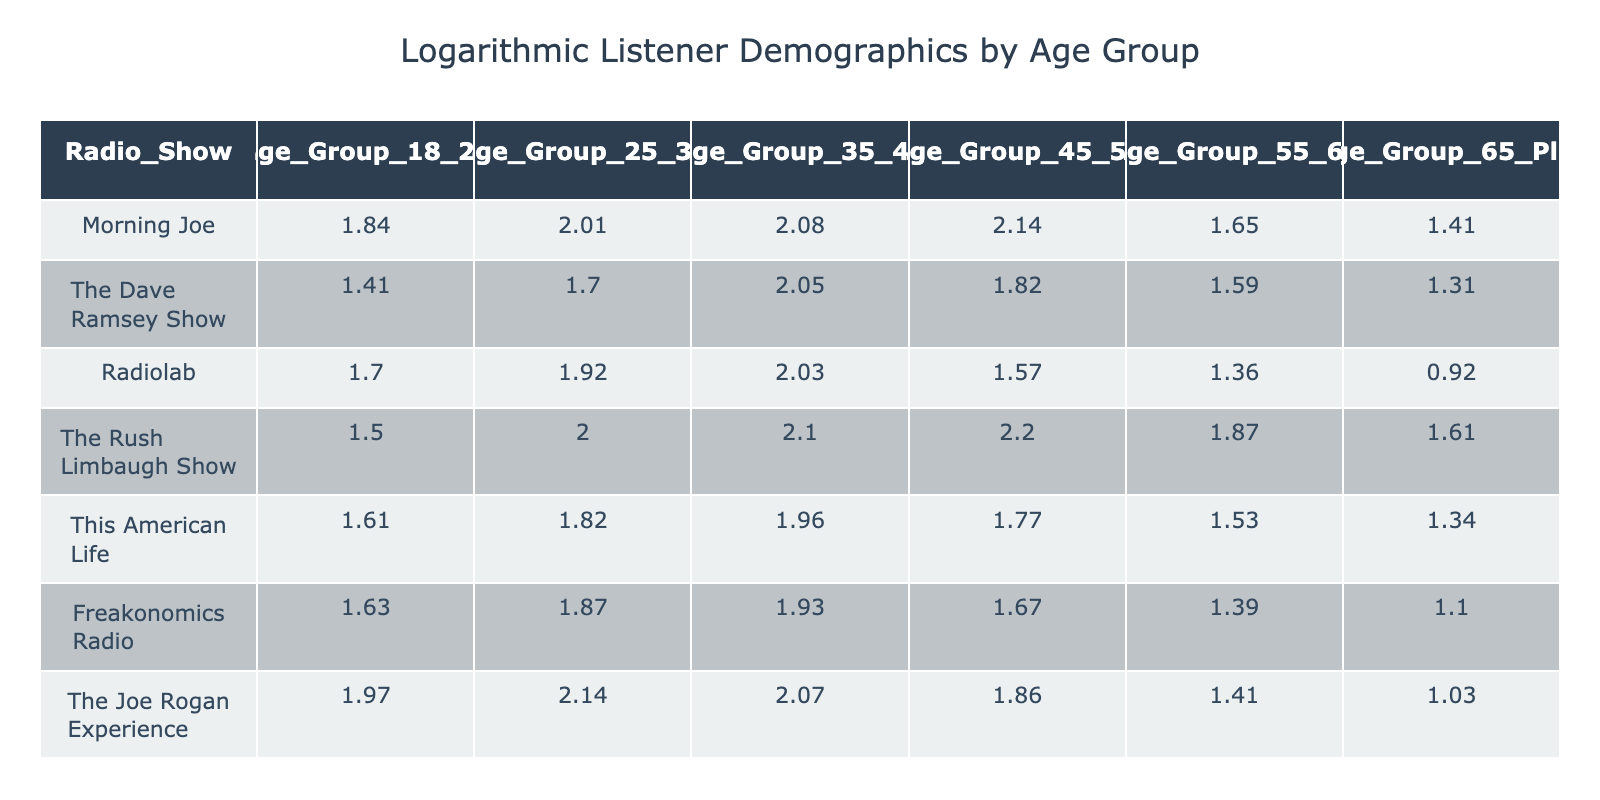What is the logarithmic value for the 45-54 age group of "Morning Joe"? The table shows "Morning Joe" has a value of 7.5 for the 45-54 age group. Thus, the logarithmic value corresponding to that age group is 7.5.
Answer: 7.5 Which radio show has the highest logarithmic value in the 35-44 age group? By looking at the 35-44 age group column, "The Rush Limbaugh Show" has the highest value of 7.2 compared to others.
Answer: The Rush Limbaugh Show What is the average logarithmic value for the 18-24 age group across all shows? The values for the 18-24 age group are 5.3, 3.1, 4.5, 3.5, 4.0, 4.1, and 6.2. Adding those gives 26.7. There are 7 shows, so the average is 26.7 / 7 = 3.81 (rounded).
Answer: 3.81 Is the logarithmic value for "This American Life" in the 55-64 age group greater than 3? The table indicates that the logarithmic value for "This American Life" in the 55-64 age group is 3.6. Therefore, it is indeed greater than 3.
Answer: Yes Which age group has the lowest average logarithmic value across all radio shows? We calculate the average for each age group. The values are: 18-24 age group: (5.3 + 3.1 + 4.5 + 3.5 + 4.0 + 4.1 + 6.2) / 7 = 4.03, 25-34 age group: (6.5 + 4.5 + 5.8 + 6.4 + 5.2 + 5.5 + 7.5) / 7 = 6.15, 35-44 age group: (7.0 + 6.8 + 6.6 + 7.2 + 6.1 + 5.9 + 6.9) / 7 = 6.57, 45-54 age group: (7.5 + 5.2 + 3.8 + 8.0 + 4.9 + 4.3 + 5.4) / 7 = 5.73, 55-64 age group: (4.2 + 3.9 + 2.9 + 5.5 + 3.6 + 3.0 + 1.8) / 7 = 3.57, 65 plus age group: (3.1 + 2.7 + 1.5 + 4.0 + 2.8 + 2.0 + 1.8) / 7 = 2.57. The age group 65 plus has the lowest average value.
Answer: 65 plus What is the difference in the logarithmic value between the 25-34 age group of "The Joe Rogan Experience" and "Radiolab"? For "The Joe Rogan Experience," the logarithmic value for the 25-34 age group is 7.5, and for "Radiolab" it is 5.8. The difference is 7.5 - 5.8 = 1.7.
Answer: 1.7 